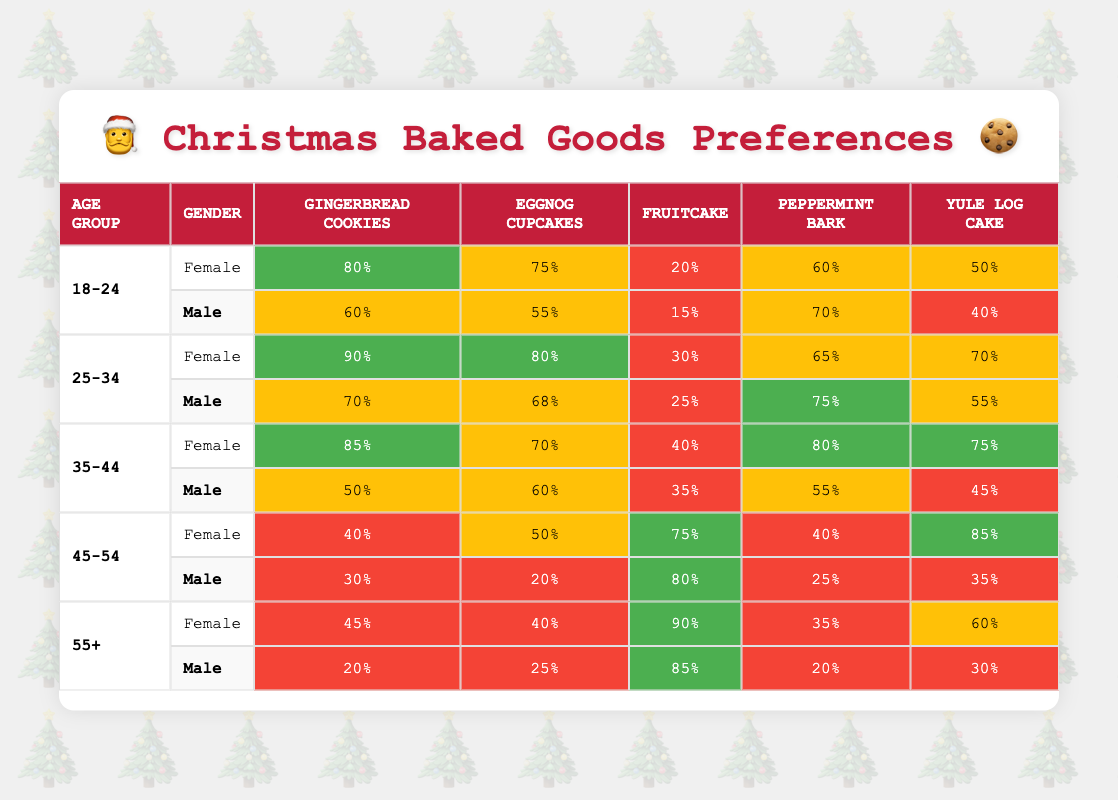What is the highest preference for Gingerbread Cookies and which group does it belong to? The highest preference for Gingerbread Cookies is 90%, which belongs to the 25-34 age group and Female gender.
Answer: 90% (25-34 Female) What is the lowest preference for Fruitcake among all age and gender groups? The lowest preference for Fruitcake is 15%, which belongs to the 18-24 age group and Male gender.
Answer: 15% (18-24 Male) Which gender group has the highest overall preference for Eggnog Cupcakes? The highest preference for Eggnog Cupcakes is 80%, which belongs to the 25-34 age group and Female gender.
Answer: 80% (25-34 Female) What is the average preference for Yule Log Cake among all Female groups? The preferences for Yule Log Cake among females are 50%, 70%, 75%, 85%, 60%. Summing these values gives 50 + 70 + 75 + 85 + 60 = 340, and dividing by 5 gives an average of 68%.
Answer: 68% Do more males or females prefer Peppermint Bark in the 35-44 age group? In the 35-44 age group, females prefer Peppermint Bark at 80%, while males prefer it at 55%. Thus, more females prefer Peppermint Bark.
Answer: Yes Which age group has the highest preference for Fruitcake? The highest preference for Fruitcake is 90%, which belongs to the 55+ age group and Female gender.
Answer: 90% (55+ Female) Is there any gender group in the 45-54 age range that prefers Yule Log Cake over 75%? In the 45-54 age group, the preference for Yule Log Cake is 85% for females, while males have a preference of 35%. This indicates that females in this age group prefer Yule Log Cake over 75%.
Answer: Yes What is the difference in preference for Gingerbread Cookies between the oldest and youngest male groups? The youngest male group (18-24) has a preference of 60% for Gingerbread Cookies, while the oldest male group (55+) has a preference of 20%. The difference is 60% - 20% = 40%.
Answer: 40% How many age groups have a preference over 70% for Eggnog Cupcakes? The age groups with preferences over 70% for Eggnog Cupcakes are 25-34 (80%) and 35-44 (70%). Therefore, there are 2 age groups with such a preference.
Answer: 2 